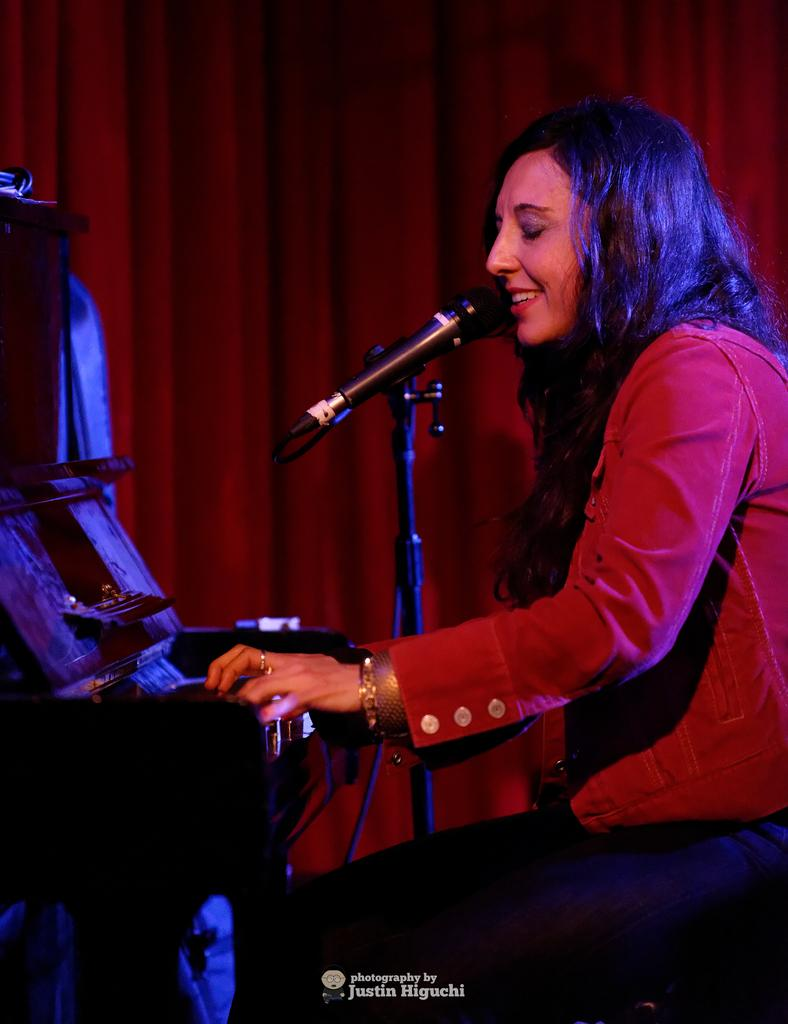Who is the main subject in the image? There is a woman in the image. What is the woman doing in the image? The woman is sitting on a chair and singing. What object is the woman using to amplify her voice? There is a microphone with a stand in the image. What instrument is the woman playing? The woman is playing a piano. What is the purpose of the curtain in the image? The curtain is in front of the piano, possibly to create a stage-like setting or to provide a visual barrier. What type of wine is the woman drinking while playing the piano? There is no wine present in the image; the woman is singing and playing the piano. Is the woman's grandmother also present in the image? There is no mention of a grandmother in the image, only the woman is visible. 